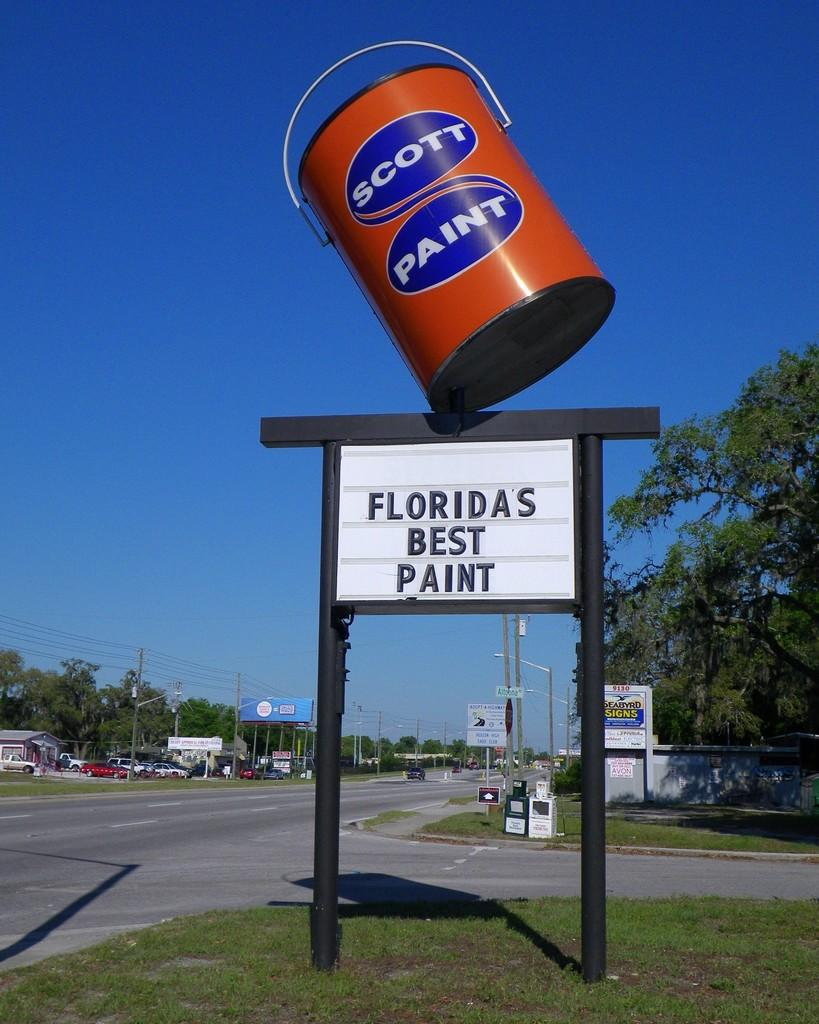<image>
Summarize the visual content of the image. the words best paint are on the sign under the paint can 